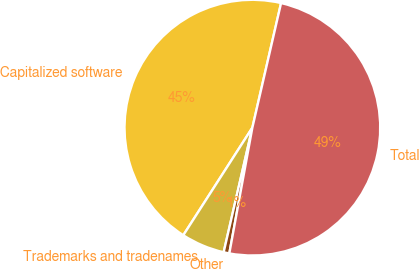<chart> <loc_0><loc_0><loc_500><loc_500><pie_chart><fcel>Capitalized software<fcel>Trademarks and tradenames<fcel>Other<fcel>Total<nl><fcel>44.52%<fcel>5.48%<fcel>0.72%<fcel>49.28%<nl></chart> 